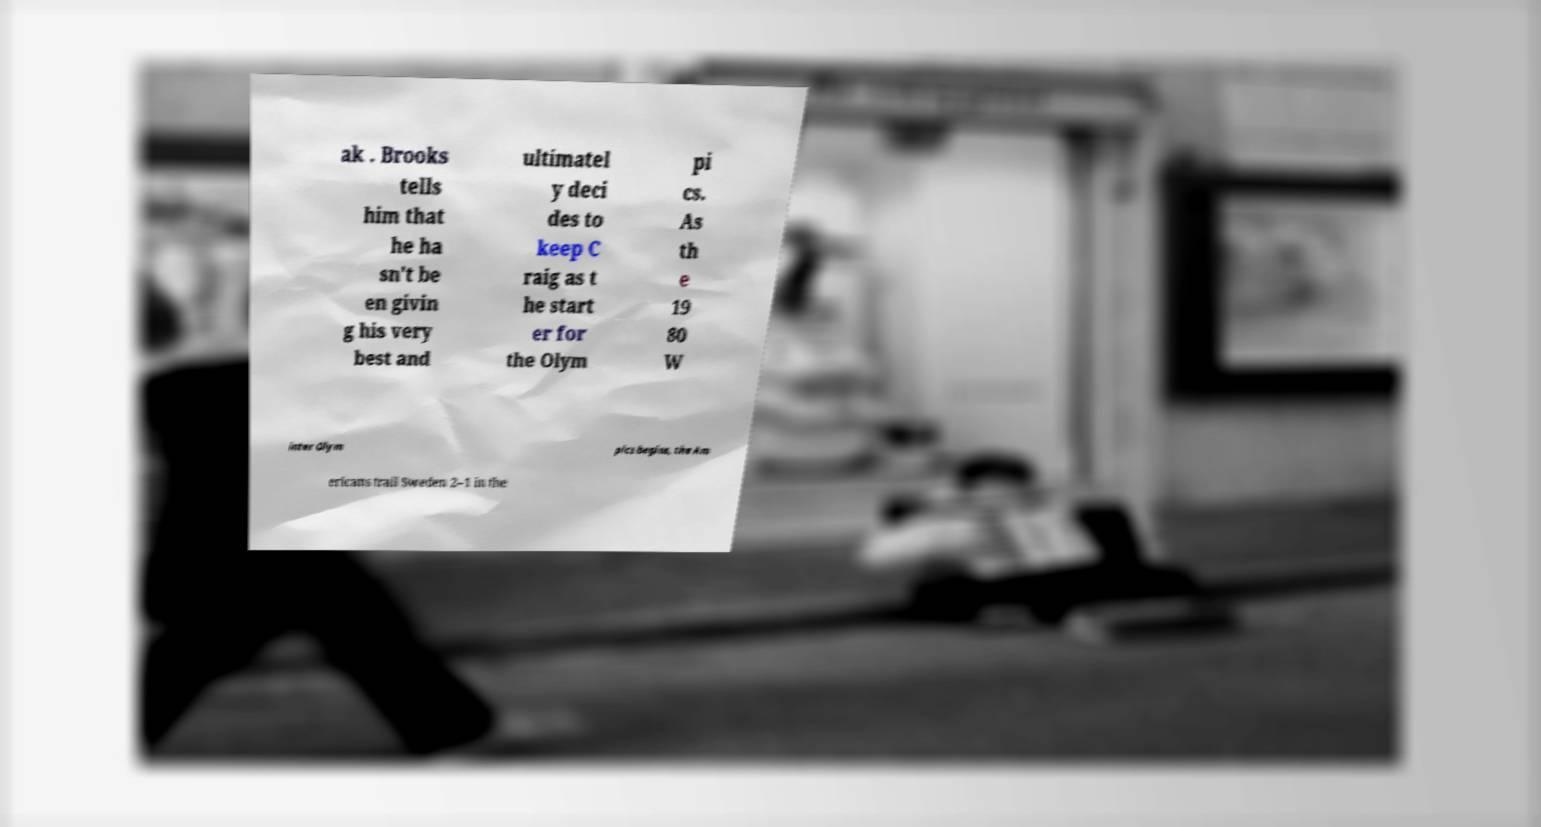For documentation purposes, I need the text within this image transcribed. Could you provide that? ak . Brooks tells him that he ha sn't be en givin g his very best and ultimatel y deci des to keep C raig as t he start er for the Olym pi cs. As th e 19 80 W inter Olym pics begins, the Am ericans trail Sweden 2–1 in the 